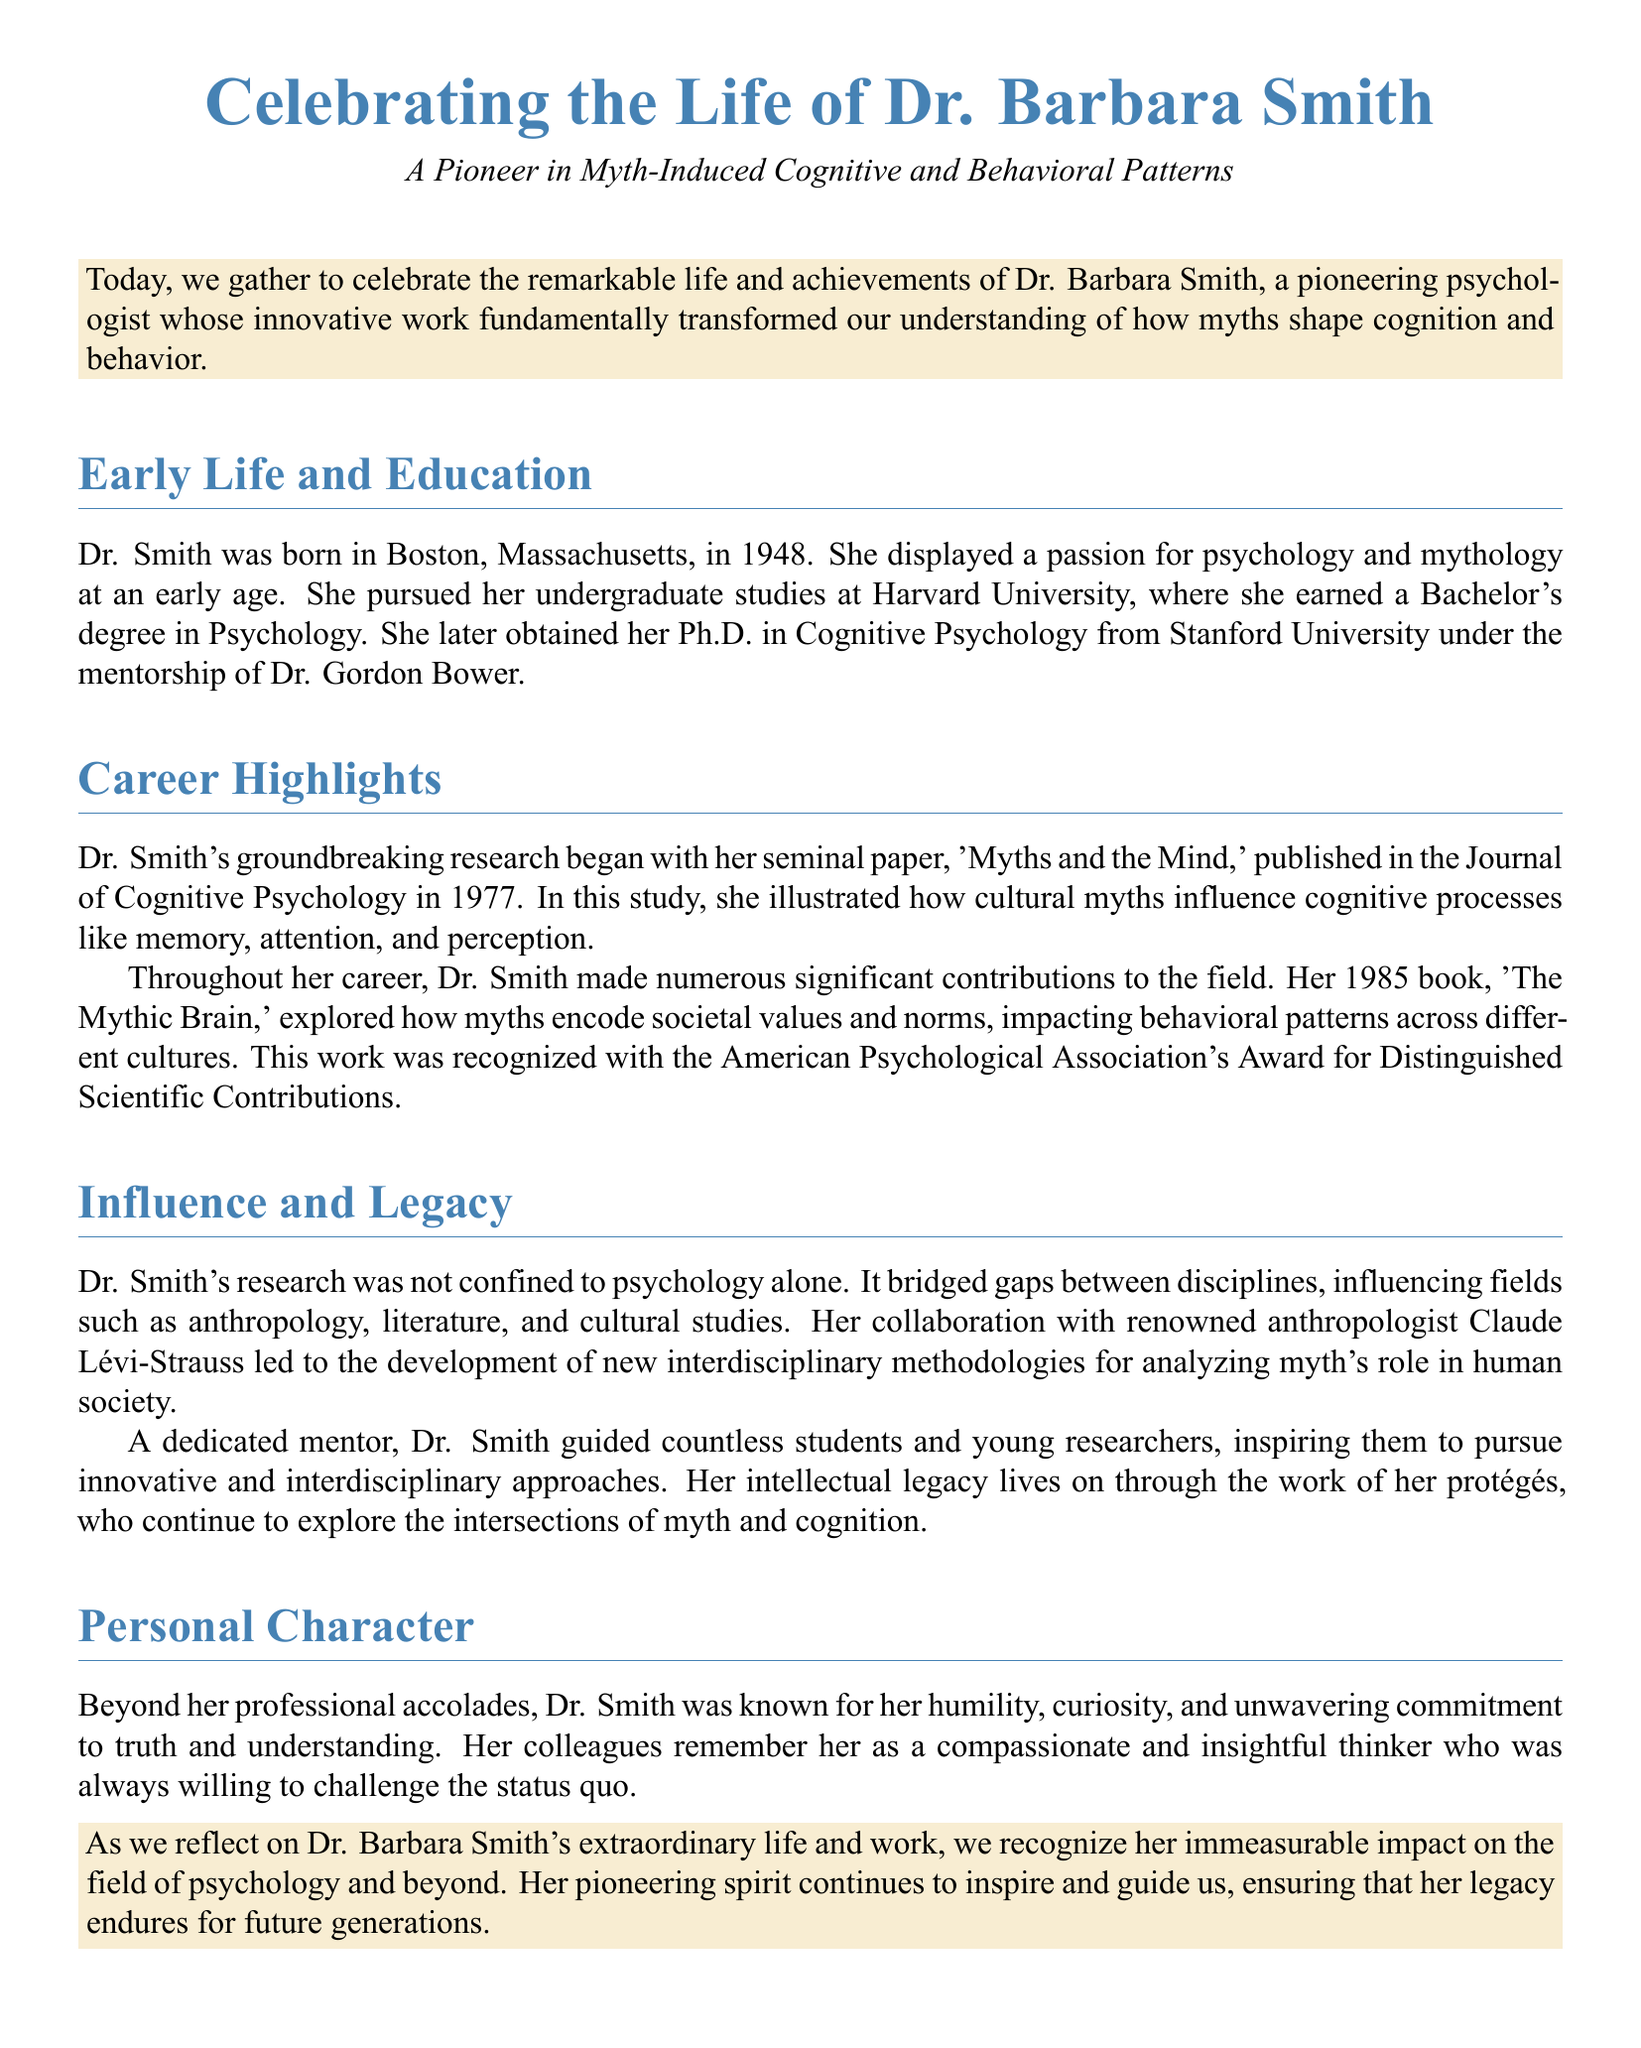What is the full name of the psychologist being celebrated? The document specifies the celebrated psychologist as Dr. Barbara Smith.
Answer: Dr. Barbara Smith In what year was Dr. Smith born? The document states that Dr. Smith was born in Boston, Massachusetts, in 1948.
Answer: 1948 What is the title of Dr. Smith's seminal paper published in 1977? The document mentions her seminal paper titled 'Myths and the Mind'.
Answer: Myths and the Mind Which award did Dr. Smith receive for her 1985 book? The document indicates she received the American Psychological Association's Award for Distinguished Scientific Contributions for her book.
Answer: American Psychological Association's Award for Distinguished Scientific Contributions Who was Dr. Smith's mentor during her Ph.D. studies? The document notes that Dr. Gordon Bower was her mentor at Stanford University.
Answer: Dr. Gordon Bower What impact did Dr. Smith’s research have on other fields? It is mentioned that her research influenced fields such as anthropology, literature, and cultural studies.
Answer: anthropology, literature, and cultural studies What character trait is Dr. Smith MOST known for, according to her colleagues? The document highlights her humility as one of her most notable character traits.
Answer: humility What year did Dr. Smith publish 'The Mythic Brain'? The document specifies that 'The Mythic Brain' was published in 1985.
Answer: 1985 How does the document describe Dr. Smith's approach to mentorship? It describes her as a dedicated mentor who inspired her protégés to pursue innovative approaches.
Answer: dedicated mentor 